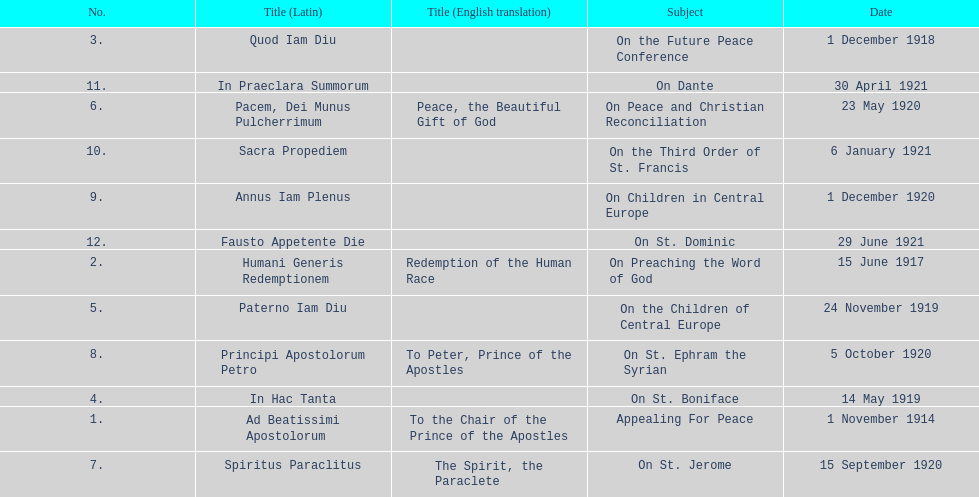What is the next title listed after sacra propediem? In Praeclara Summorum. Parse the table in full. {'header': ['No.', 'Title (Latin)', 'Title (English translation)', 'Subject', 'Date'], 'rows': [['3.', 'Quod Iam Diu', '', 'On the Future Peace Conference', '1 December 1918'], ['11.', 'In Praeclara Summorum', '', 'On Dante', '30 April 1921'], ['6.', 'Pacem, Dei Munus Pulcherrimum', 'Peace, the Beautiful Gift of God', 'On Peace and Christian Reconciliation', '23 May 1920'], ['10.', 'Sacra Propediem', '', 'On the Third Order of St. Francis', '6 January 1921'], ['9.', 'Annus Iam Plenus', '', 'On Children in Central Europe', '1 December 1920'], ['12.', 'Fausto Appetente Die', '', 'On St. Dominic', '29 June 1921'], ['2.', 'Humani Generis Redemptionem', 'Redemption of the Human Race', 'On Preaching the Word of God', '15 June 1917'], ['5.', 'Paterno Iam Diu', '', 'On the Children of Central Europe', '24 November 1919'], ['8.', 'Principi Apostolorum Petro', 'To Peter, Prince of the Apostles', 'On St. Ephram the Syrian', '5 October 1920'], ['4.', 'In Hac Tanta', '', 'On St. Boniface', '14 May 1919'], ['1.', 'Ad Beatissimi Apostolorum', 'To the Chair of the Prince of the Apostles', 'Appealing For Peace', '1 November 1914'], ['7.', 'Spiritus Paraclitus', 'The Spirit, the Paraclete', 'On St. Jerome', '15 September 1920']]} 